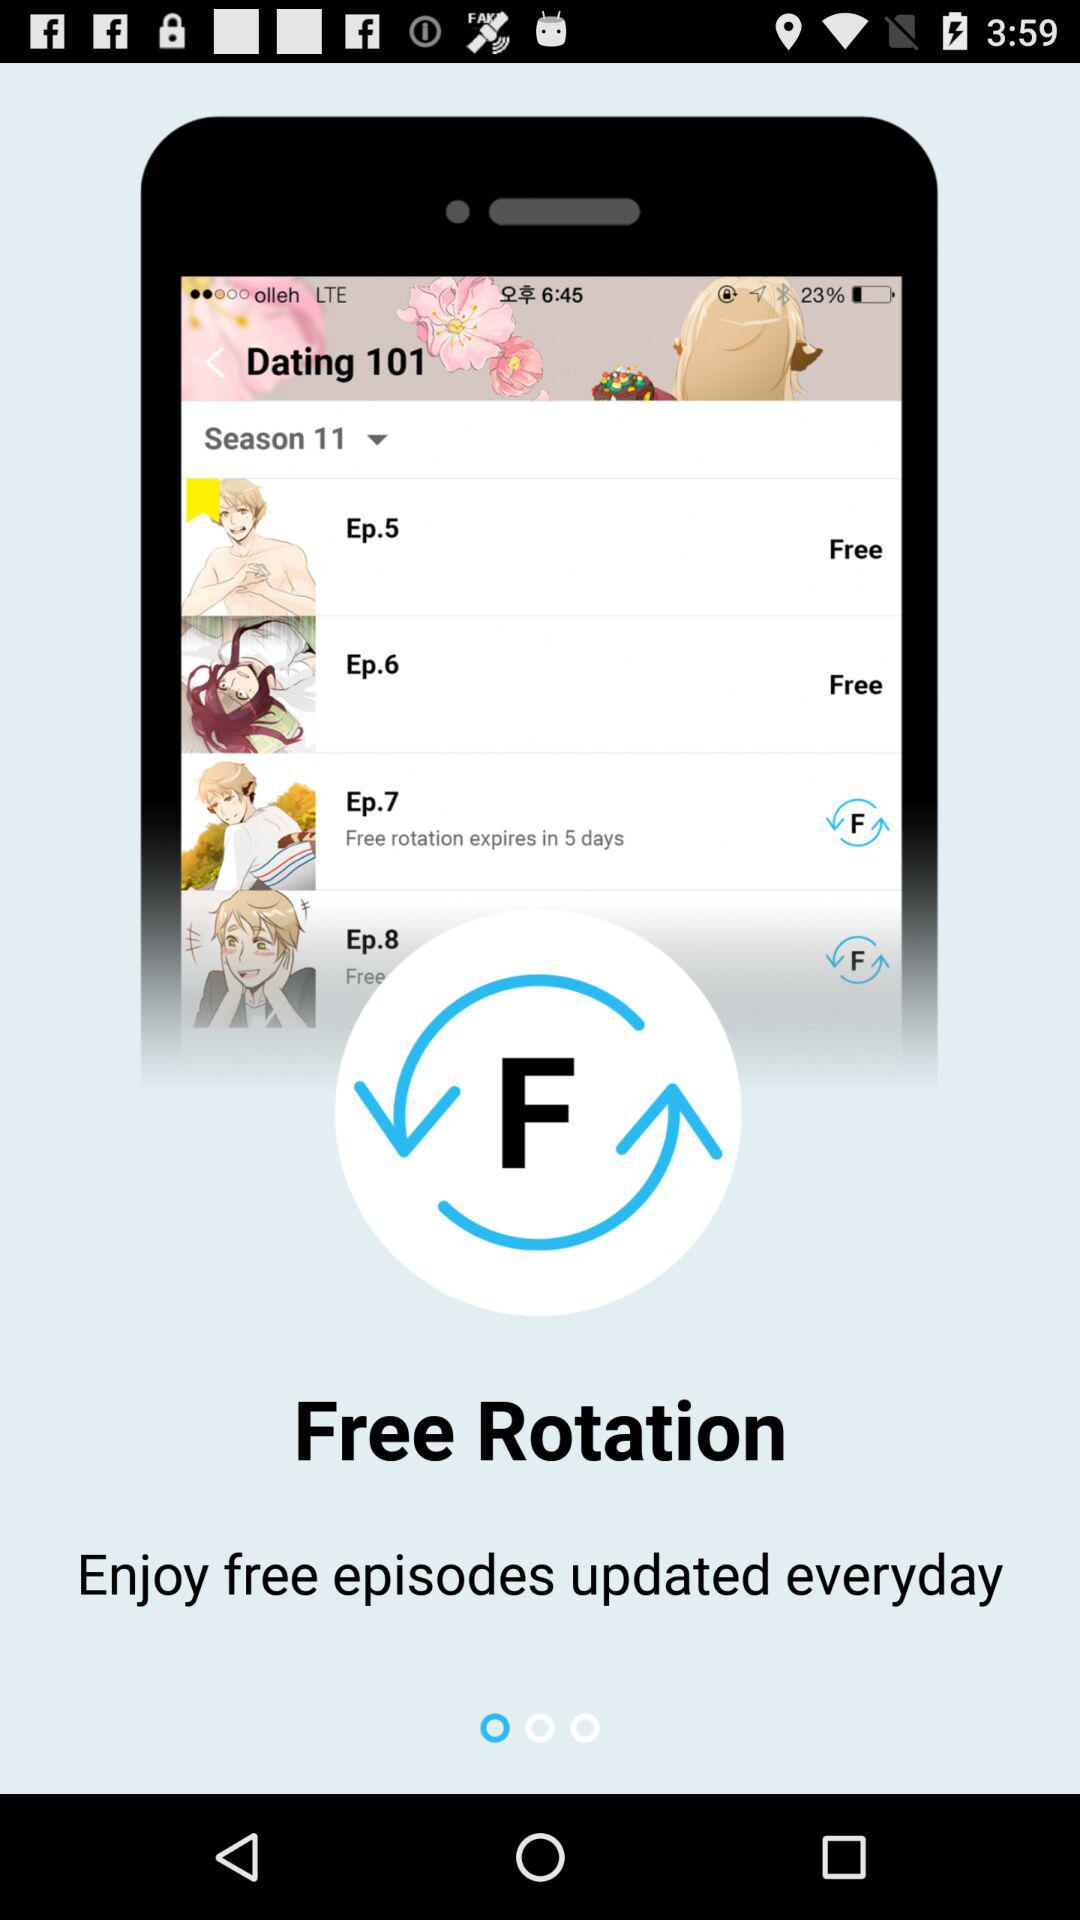What is the name of the series? The name of the series is "Dating 101". 